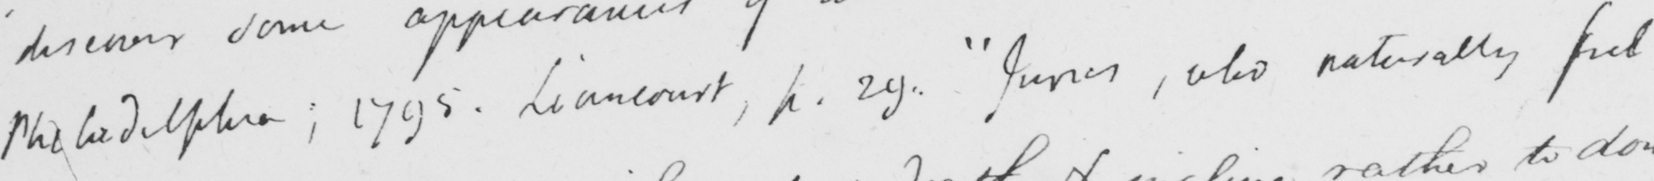Please transcribe the handwritten text in this image. Philadelphia ; 1795 . Liancourt , p . 29 .  " Juries , who naturally feel 